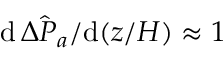<formula> <loc_0><loc_0><loc_500><loc_500>d \, \hat { \Delta P _ { a } } / d ( z / H ) \approx 1</formula> 